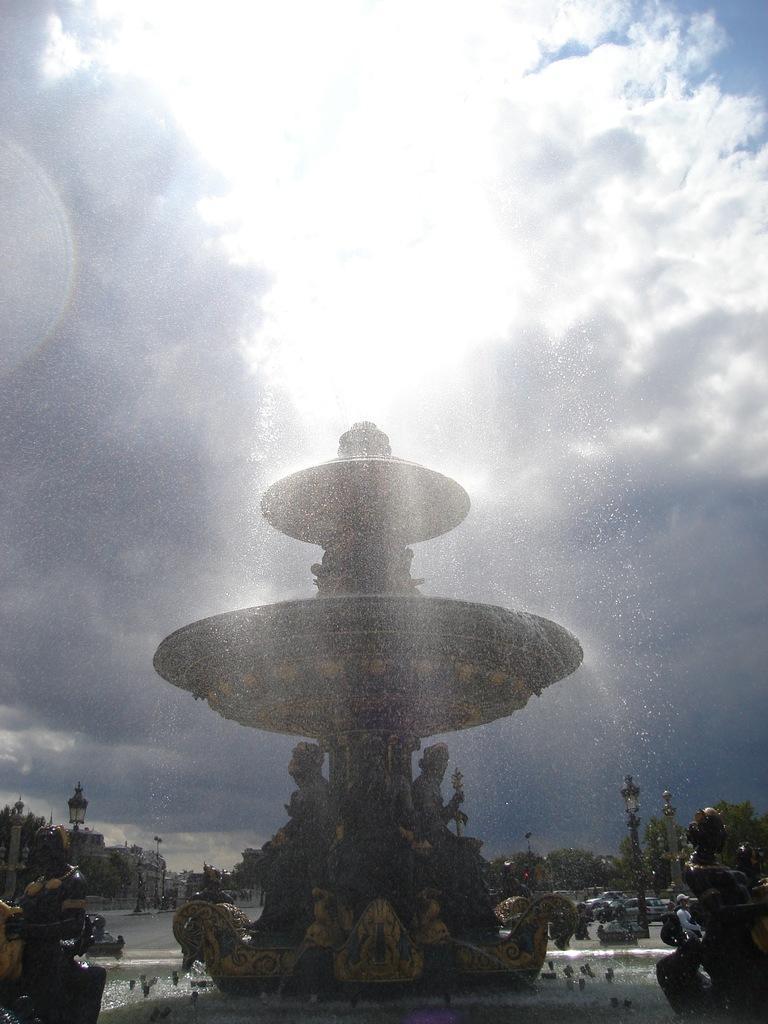Describe this image in one or two sentences. In this image we can see a fountain. Behind the fountain we can see vehicles, trees, persons and poles with lights. At the top we can see the sky. At the bottom we can see the statues. 